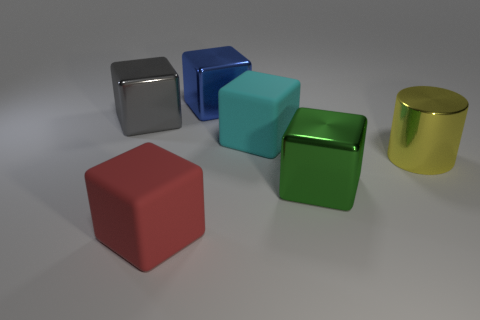Subtract all gray metallic blocks. How many blocks are left? 4 Subtract all red blocks. How many blocks are left? 4 Add 2 big blue metallic cubes. How many objects exist? 8 Subtract 1 cubes. How many cubes are left? 4 Subtract all blocks. How many objects are left? 1 Subtract all yellow cubes. Subtract all yellow cylinders. How many cubes are left? 5 Add 5 green objects. How many green objects exist? 6 Subtract 1 blue blocks. How many objects are left? 5 Subtract all large rubber things. Subtract all big blue metal cubes. How many objects are left? 3 Add 1 big blue objects. How many big blue objects are left? 2 